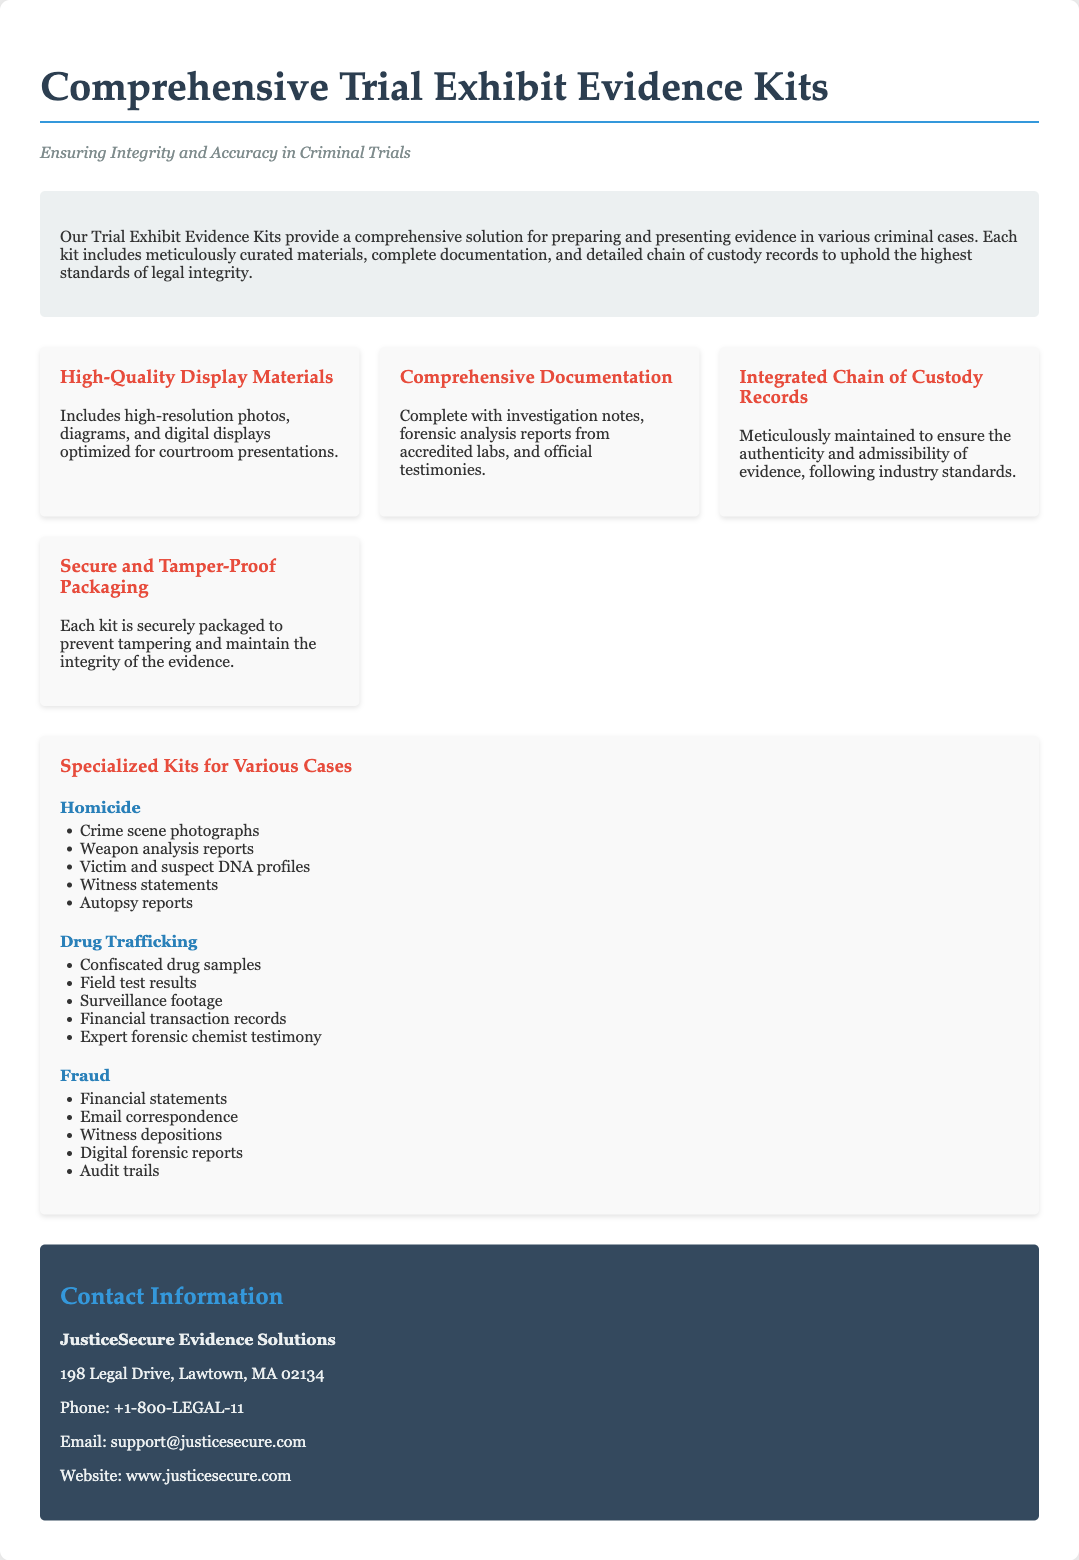What company provides these kits? The document explicitly states the provider of the kits at the end in the contact section.
Answer: JusticeSecure Evidence Solutions What is included in the "High-Quality Display Materials"? This is detailed in the features section, specifically under the high-quality display materials description.
Answer: High-resolution photos, diagrams, and digital displays How many types of case kits are mentioned? This can be counted from the sections describing specialized kits for various cases.
Answer: Three What type of cases are covered in the specialized kits? The kits for various cases are explicitly outlined, mentioning key case types only.
Answer: Homicide, Drug Trafficking, Fraud What does the term "Chain of Custody" refer to in this context? The document mentions the chain of custody in reference to its importance for evidence admissibility, explaining what it entails.
Answer: Meticulously maintained records What is the contact phone number for JusticeSecure Evidence Solutions? This specific information is provided in the contact section of the document.
Answer: +1-800-LEGAL-11 What type of evidence is included in the Drug Trafficking kit? This question refers to the detailed list of items provided under the Drug Trafficking case type in the document.
Answer: Confiscated drug samples, field test results, surveillance footage, financial transaction records, expert forensic chemist testimony What is the objective of the Trial Exhibit Evidence Kits? The primary purpose of the kits is summarized in the introductory paragraph of the document.
Answer: Ensuring integrity and accuracy in criminal trials 